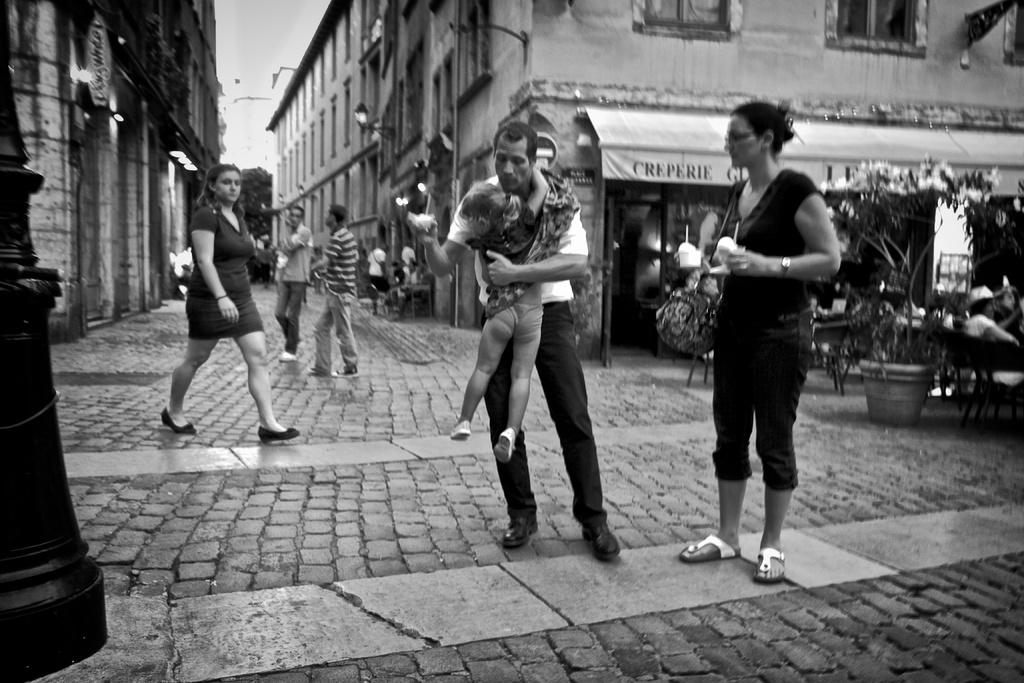What is happening in the image? There are people standing in the image. What can be seen on the right side of the image? There is a flower pot on the right side of the image. What is visible in the background of the image? There are buildings in the background of the image. What is attached to the wall in the image? There are lights on the wall in the image. What nation is represented by the flag on the wall in the image? There is no flag visible in the image, so it is not possible to determine which nation might be represented. 